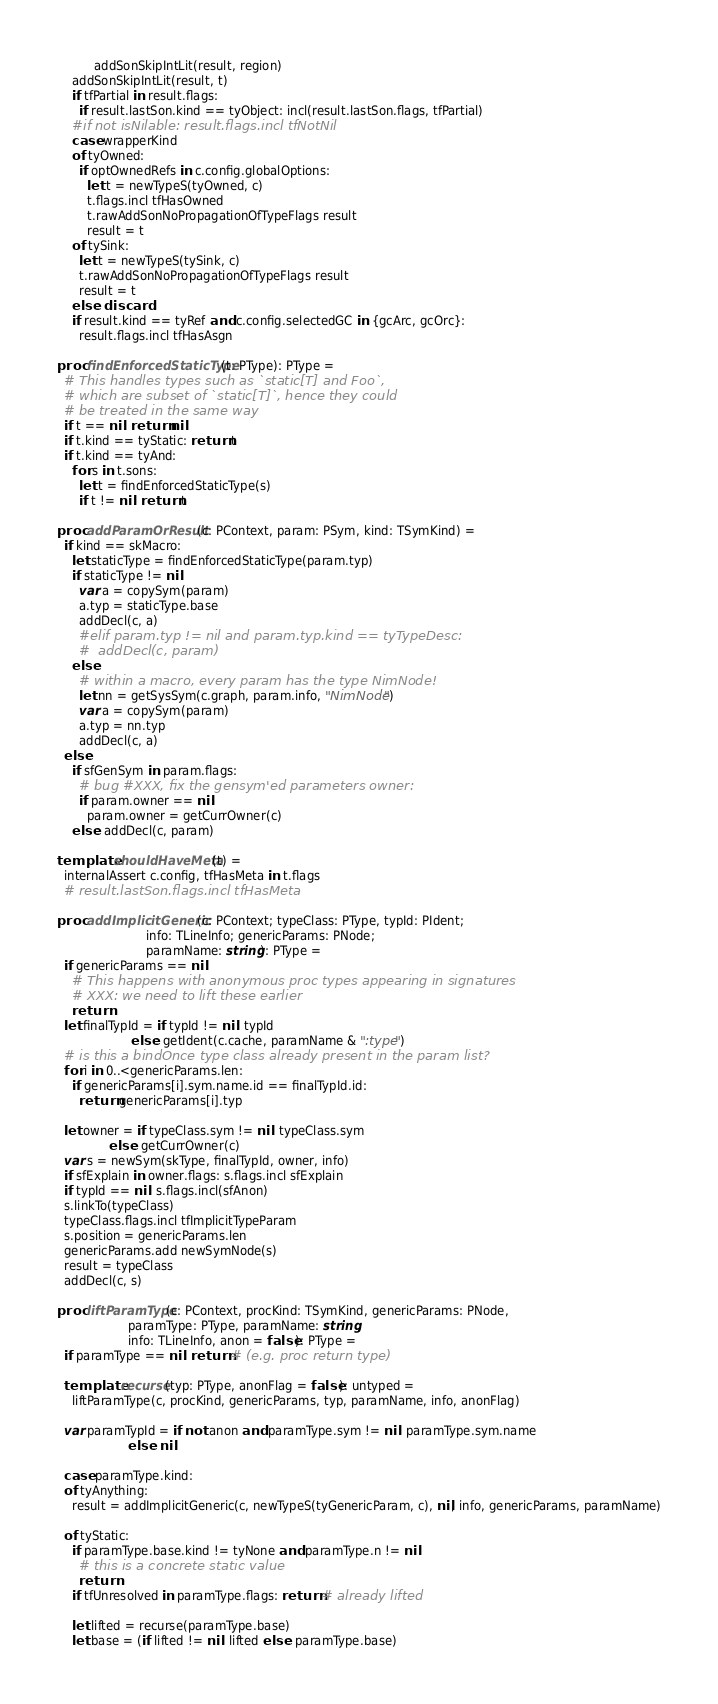<code> <loc_0><loc_0><loc_500><loc_500><_Nim_>          addSonSkipIntLit(result, region)
    addSonSkipIntLit(result, t)
    if tfPartial in result.flags:
      if result.lastSon.kind == tyObject: incl(result.lastSon.flags, tfPartial)
    #if not isNilable: result.flags.incl tfNotNil
    case wrapperKind
    of tyOwned:
      if optOwnedRefs in c.config.globalOptions:
        let t = newTypeS(tyOwned, c)
        t.flags.incl tfHasOwned
        t.rawAddSonNoPropagationOfTypeFlags result
        result = t
    of tySink:
      let t = newTypeS(tySink, c)
      t.rawAddSonNoPropagationOfTypeFlags result
      result = t
    else: discard
    if result.kind == tyRef and c.config.selectedGC in {gcArc, gcOrc}:
      result.flags.incl tfHasAsgn

proc findEnforcedStaticType(t: PType): PType =
  # This handles types such as `static[T] and Foo`,
  # which are subset of `static[T]`, hence they could
  # be treated in the same way
  if t == nil: return nil
  if t.kind == tyStatic: return t
  if t.kind == tyAnd:
    for s in t.sons:
      let t = findEnforcedStaticType(s)
      if t != nil: return t

proc addParamOrResult(c: PContext, param: PSym, kind: TSymKind) =
  if kind == skMacro:
    let staticType = findEnforcedStaticType(param.typ)
    if staticType != nil:
      var a = copySym(param)
      a.typ = staticType.base
      addDecl(c, a)
      #elif param.typ != nil and param.typ.kind == tyTypeDesc:
      #  addDecl(c, param)
    else:
      # within a macro, every param has the type NimNode!
      let nn = getSysSym(c.graph, param.info, "NimNode")
      var a = copySym(param)
      a.typ = nn.typ
      addDecl(c, a)
  else:
    if sfGenSym in param.flags:
      # bug #XXX, fix the gensym'ed parameters owner:
      if param.owner == nil:
        param.owner = getCurrOwner(c)
    else: addDecl(c, param)

template shouldHaveMeta(t) =
  internalAssert c.config, tfHasMeta in t.flags
  # result.lastSon.flags.incl tfHasMeta

proc addImplicitGeneric(c: PContext; typeClass: PType, typId: PIdent;
                        info: TLineInfo; genericParams: PNode;
                        paramName: string): PType =
  if genericParams == nil:
    # This happens with anonymous proc types appearing in signatures
    # XXX: we need to lift these earlier
    return
  let finalTypId = if typId != nil: typId
                    else: getIdent(c.cache, paramName & ":type")
  # is this a bindOnce type class already present in the param list?
  for i in 0..<genericParams.len:
    if genericParams[i].sym.name.id == finalTypId.id:
      return genericParams[i].typ

  let owner = if typeClass.sym != nil: typeClass.sym
              else: getCurrOwner(c)
  var s = newSym(skType, finalTypId, owner, info)
  if sfExplain in owner.flags: s.flags.incl sfExplain
  if typId == nil: s.flags.incl(sfAnon)
  s.linkTo(typeClass)
  typeClass.flags.incl tfImplicitTypeParam
  s.position = genericParams.len
  genericParams.add newSymNode(s)
  result = typeClass
  addDecl(c, s)

proc liftParamType(c: PContext, procKind: TSymKind, genericParams: PNode,
                   paramType: PType, paramName: string,
                   info: TLineInfo, anon = false): PType =
  if paramType == nil: return # (e.g. proc return type)

  template recurse(typ: PType, anonFlag = false): untyped =
    liftParamType(c, procKind, genericParams, typ, paramName, info, anonFlag)

  var paramTypId = if not anon and paramType.sym != nil: paramType.sym.name
                   else: nil

  case paramType.kind:
  of tyAnything:
    result = addImplicitGeneric(c, newTypeS(tyGenericParam, c), nil, info, genericParams, paramName)

  of tyStatic:
    if paramType.base.kind != tyNone and paramType.n != nil:
      # this is a concrete static value
      return
    if tfUnresolved in paramType.flags: return # already lifted

    let lifted = recurse(paramType.base)
    let base = (if lifted != nil: lifted else: paramType.base)</code> 